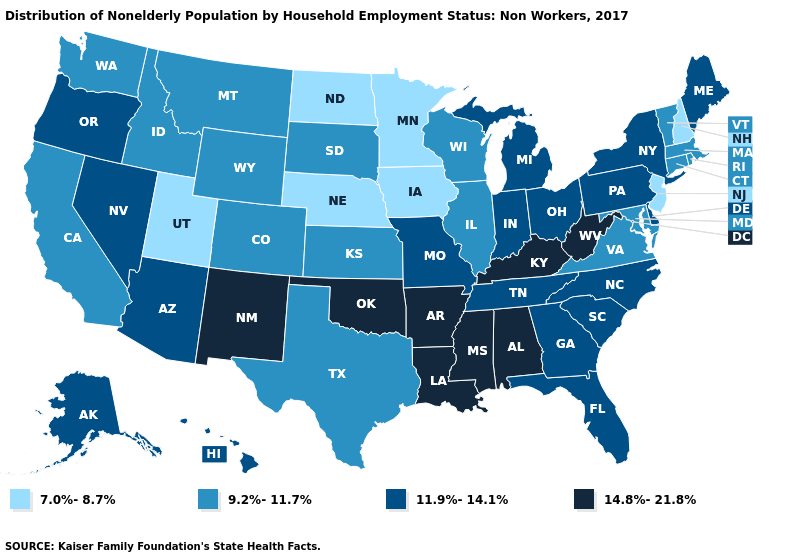Among the states that border Nebraska , which have the lowest value?
Give a very brief answer. Iowa. What is the value of West Virginia?
Concise answer only. 14.8%-21.8%. Does the map have missing data?
Answer briefly. No. Name the states that have a value in the range 7.0%-8.7%?
Answer briefly. Iowa, Minnesota, Nebraska, New Hampshire, New Jersey, North Dakota, Utah. What is the highest value in the USA?
Keep it brief. 14.8%-21.8%. Does the map have missing data?
Concise answer only. No. Does New Mexico have the highest value in the West?
Keep it brief. Yes. What is the value of Florida?
Concise answer only. 11.9%-14.1%. What is the value of Ohio?
Keep it brief. 11.9%-14.1%. What is the lowest value in the USA?
Short answer required. 7.0%-8.7%. Name the states that have a value in the range 11.9%-14.1%?
Concise answer only. Alaska, Arizona, Delaware, Florida, Georgia, Hawaii, Indiana, Maine, Michigan, Missouri, Nevada, New York, North Carolina, Ohio, Oregon, Pennsylvania, South Carolina, Tennessee. What is the value of Arkansas?
Be succinct. 14.8%-21.8%. Does the first symbol in the legend represent the smallest category?
Answer briefly. Yes. What is the highest value in the USA?
Give a very brief answer. 14.8%-21.8%. What is the value of Colorado?
Keep it brief. 9.2%-11.7%. 